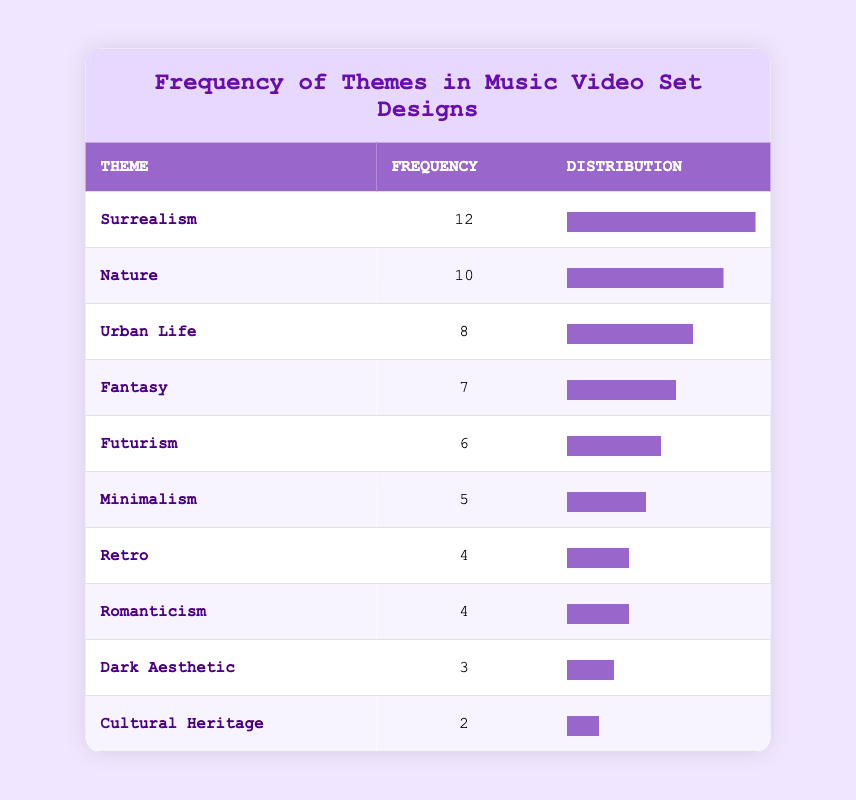What is the most frequently explored theme in the music video set designs? The table lists the frequencies of themes, where "Surrealism" has the highest frequency of 12 compared to the other themes.
Answer: Surrealism How many themes have a frequency of 4 or more? The themes that have a frequency of 4 or more are Surrealism (12), Nature (10), Urban Life (8), Fantasy (7), Futurism (6), Minimalism (5), Retro (4), and Romanticism (4). Counting these themes gives us a total of 8 themes.
Answer: 8 What is the frequency difference between the theme with the highest and the theme with the lowest frequency? The highest frequency is from "Surrealism" with 12 and the lowest frequency is from "Cultural Heritage" with 2. The difference is calculated as 12 - 2 = 10.
Answer: 10 Is there a theme that explores both Nature and Urban Life? Based on the table, "Nature" and "Urban Life" are listed as distinct themes, indicating that there is no theme that encompasses both.
Answer: No What is the average frequency of all the themes listed in the table? To find the average, first sum the frequencies: 12 + 10 + 8 + 6 + 7 + 5 + 4 + 4 + 3 + 2 = 61. There are 10 themes, so the average is calculated as 61 / 10 = 6.1.
Answer: 6.1 How many themes relate to aesthetic styles (e.g., Dark Aesthetic, Retro, and Minimalism)? The themes that relate to aesthetic styles include Dark Aesthetic, Retro, Minimalism, and Surrealism (which is often considered an aesthetic). Counting these gives a total of 4 themes related to aesthetic styles.
Answer: 4 What percentage of the themes has a frequency of less than 5? The themes with a frequency of less than 5 are Dark Aesthetic (3), Cultural Heritage (2), and Retro (4). There are 3 such themes out of a total of 10, so the percentage is (3/10) * 100 = 30%.
Answer: 30% Which theme has a frequency closest to the average frequency of the themes? The average frequency is 6.1, and the closest frequencies are from Futurism with 6 and Fantasy with 7. Both are closest to the average.
Answer: Futurism and Fantasy 